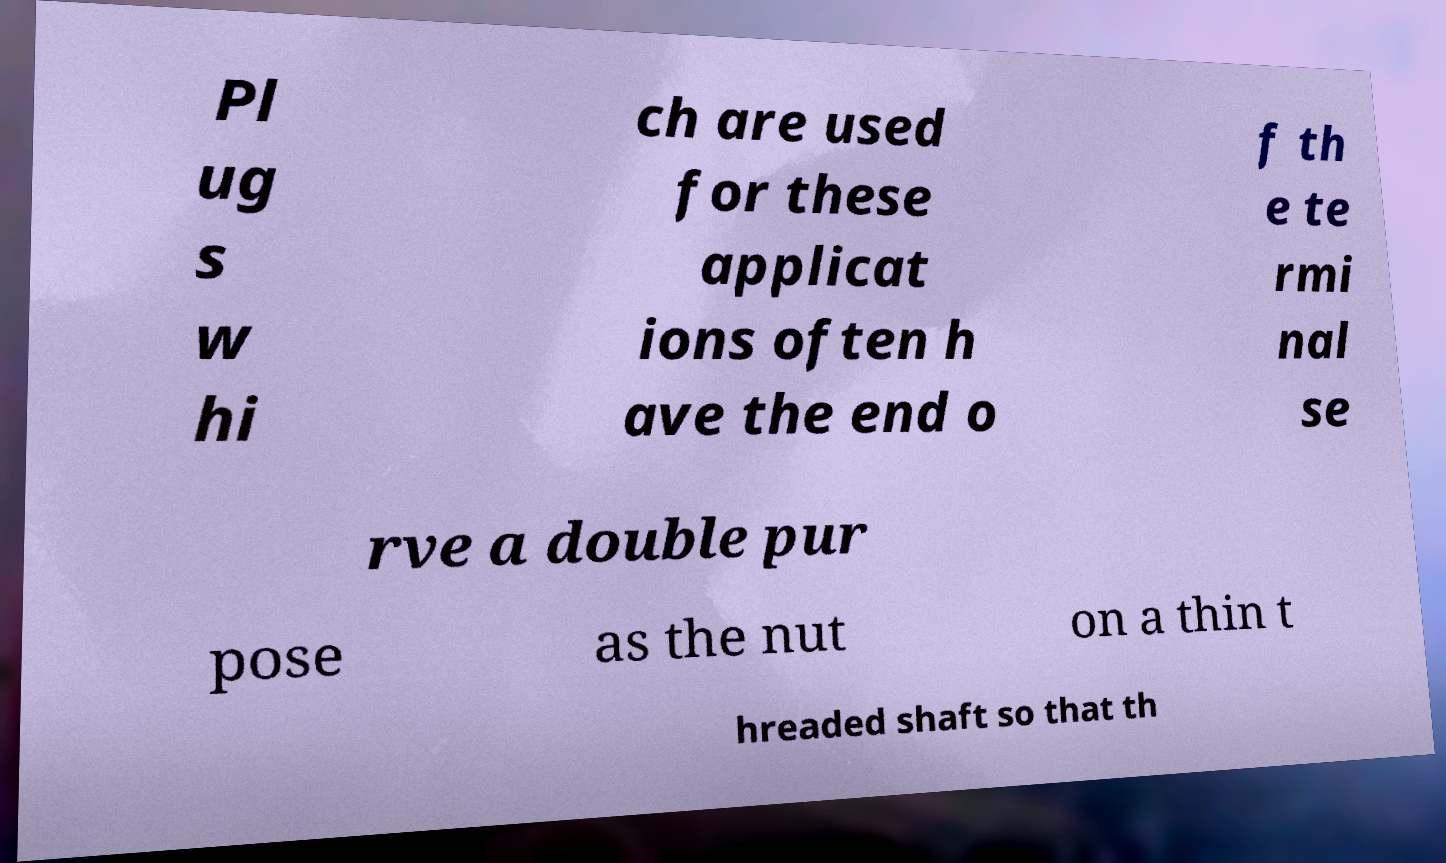Could you extract and type out the text from this image? Pl ug s w hi ch are used for these applicat ions often h ave the end o f th e te rmi nal se rve a double pur pose as the nut on a thin t hreaded shaft so that th 